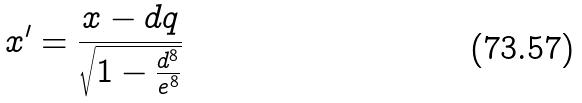<formula> <loc_0><loc_0><loc_500><loc_500>x ^ { \prime } = \frac { x - d q } { \sqrt { 1 - \frac { d ^ { 8 } } { e ^ { 8 } } } }</formula> 